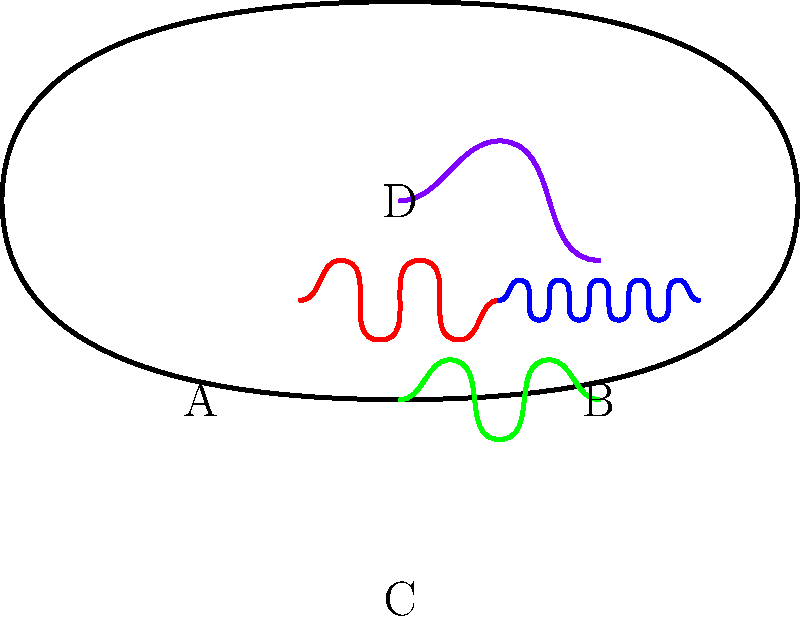In the given 2D topographic brain map, four distinct EEG wave patterns are visible in different regions (A, B, C, and D). Which region displays beta waves, typically associated with active thinking and focus? To answer this question, we need to analyze the EEG wave patterns in each region and identify the characteristics of beta waves:

1. Beta waves are characterized by their high frequency (13-30 Hz) and relatively low amplitude. They appear as rapid, closely spaced oscillations.

2. Examining each region:
   A (Left): Shows a pattern with moderate frequency and amplitude, consistent with alpha waves (8-13 Hz).
   B (Right): Displays a high-frequency, low-amplitude pattern with closely spaced oscillations.
   C (Bottom): Exhibits a pattern with lower frequency and higher amplitude, typical of theta waves (4-8 Hz).
   D (Top): Shows a very low frequency, high-amplitude pattern characteristic of delta waves (0.5-4 Hz).

3. The pattern in region B most closely resembles beta waves due to its high frequency and low amplitude.

4. Beta waves are indeed associated with active thinking, focus, and alert states, which aligns with the question's description.

Therefore, the region displaying beta waves is B (Right).
Answer: B 